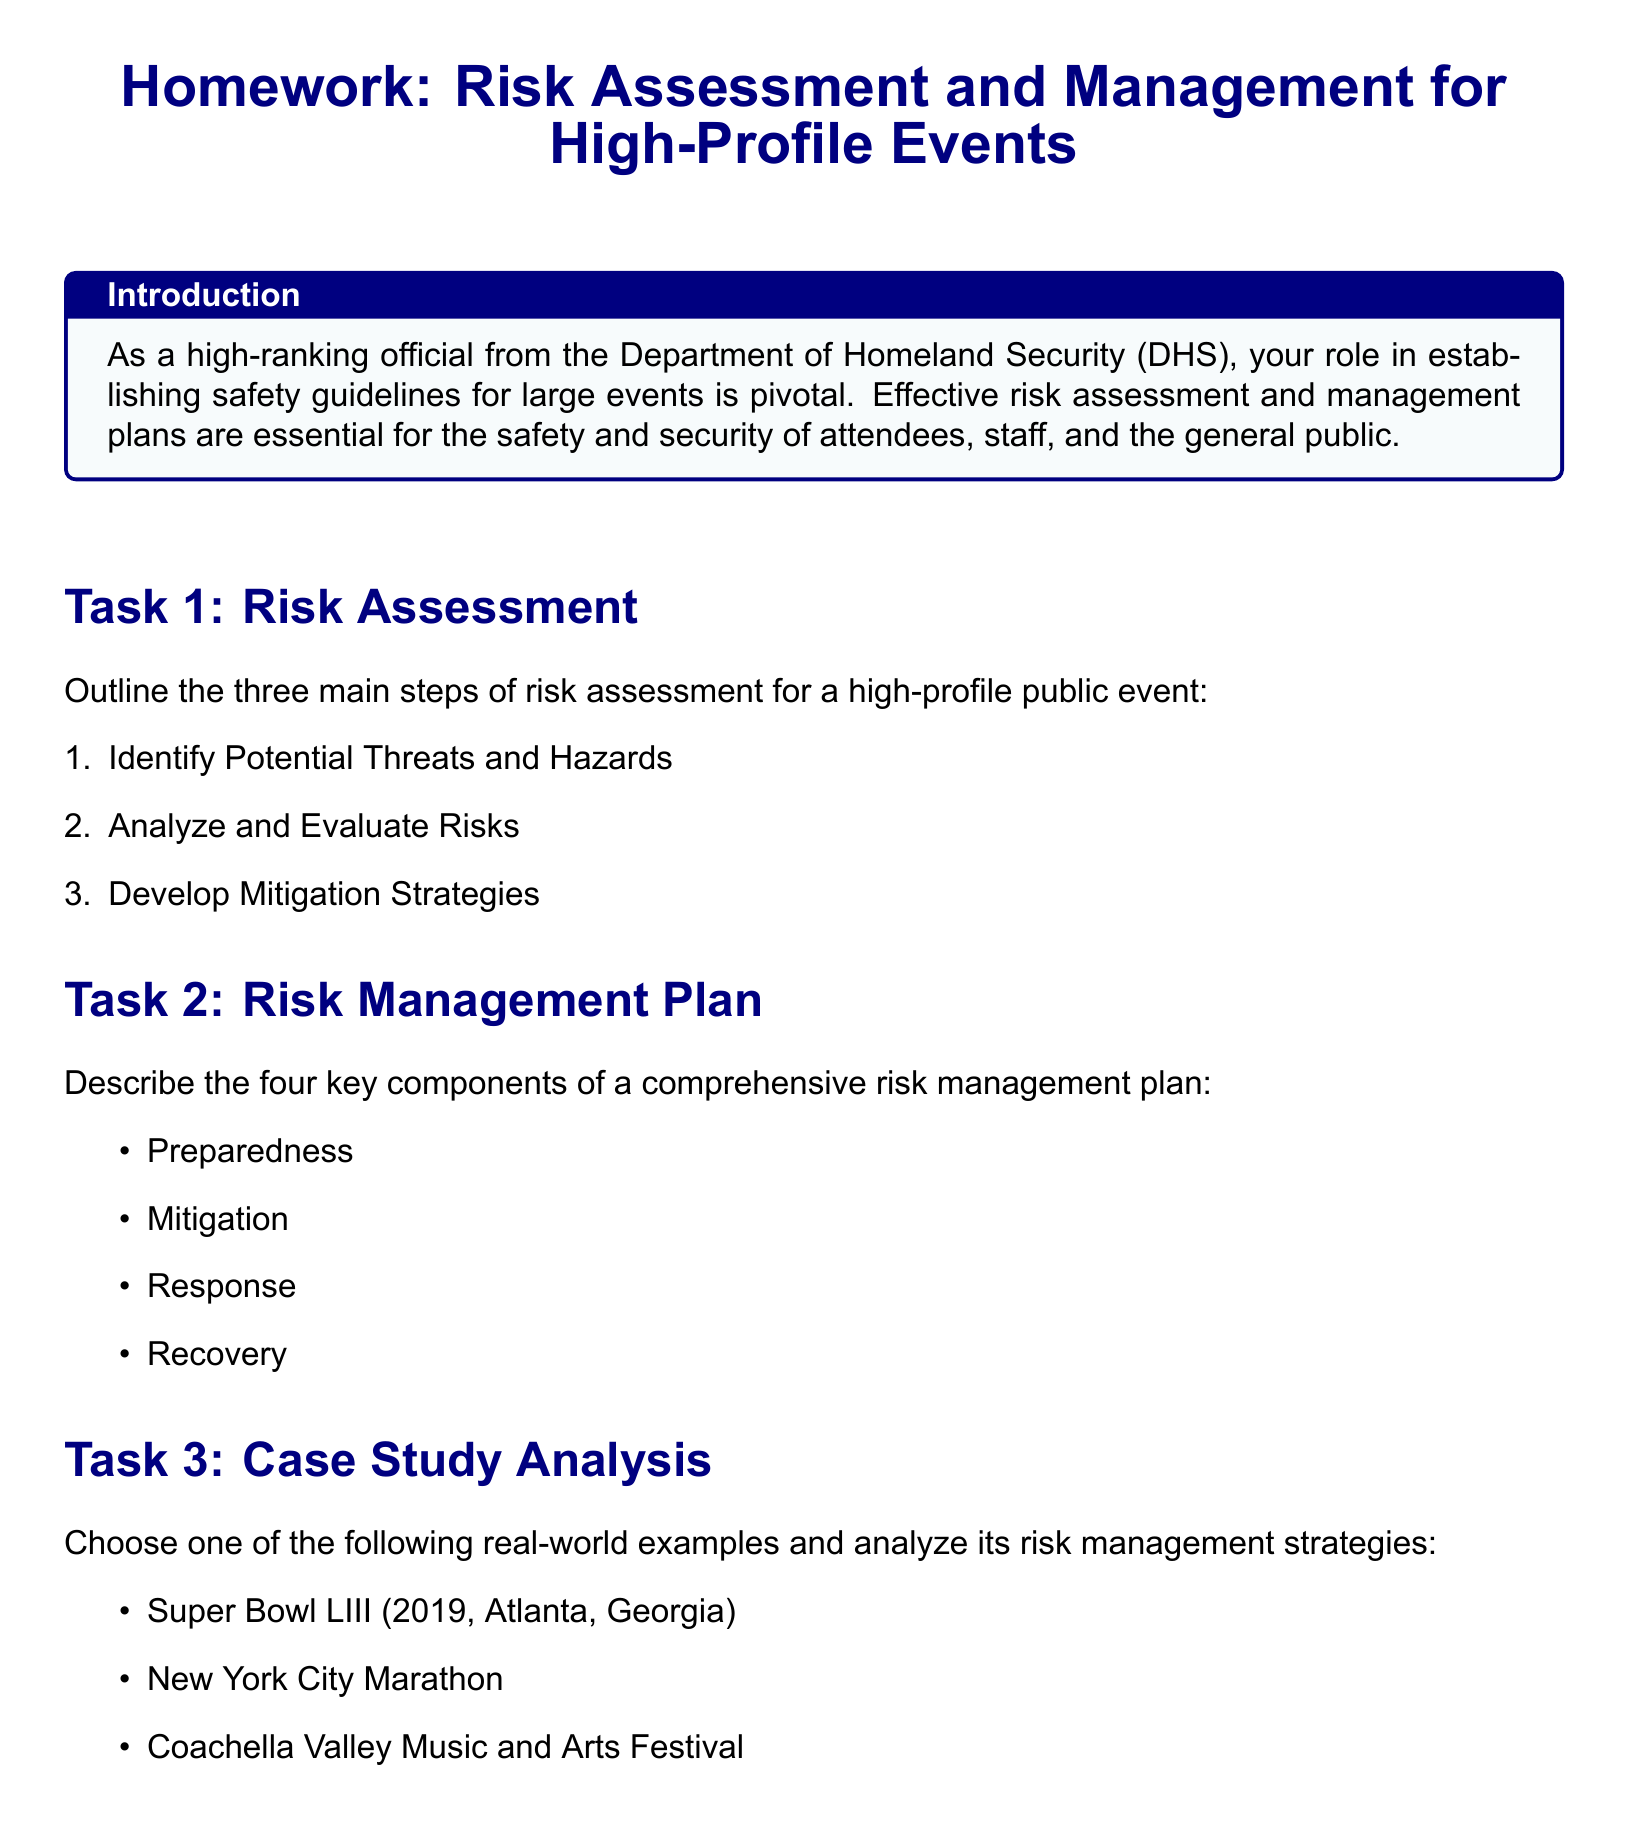What are the three main steps of risk assessment? The three main steps of risk assessment listed in the document are Identify Potential Threats and Hazards, Analyze and Evaluate Risks, and Develop Mitigation Strategies.
Answer: Identify Potential Threats and Hazards, Analyze and Evaluate Risks, Develop Mitigation Strategies What are the four key components of a risk management plan? The document outlines the four key components as Preparedness, Mitigation, Response, and Recovery.
Answer: Preparedness, Mitigation, Response, Recovery Which high-profile event is chosen in Task 3? The document allows choosing from Super Bowl LIII, New York City Marathon, or Coachella Valley Music and Arts Festival for a case study analysis in Task 3.
Answer: Super Bowl LIII, New York City Marathon, Coachella Valley Music and Arts Festival What color is used for the section titles? The document specifies that the color navy blue is used for section titles.
Answer: Navy blue What is the purpose of the conclusion section? The purpose of the conclusion section is to summarize the importance of effective risk assessment and management for the safety and success of high-profile events.
Answer: Summarize the importance of effective risk assessment and management How many tasks are present in the homework? The document outlines a total of four tasks that need to be completed in the homework assignment.
Answer: Four What type of document is this? The document is a homework assignment focused on Risk Assessment and Management for High-Profile Events.
Answer: Homework assignment What is the intended audience for this homework? The intended audience for this homework is officials such as high-ranking officials from the Department of Homeland Security.
Answer: High-ranking officials from the Department of Homeland Security 